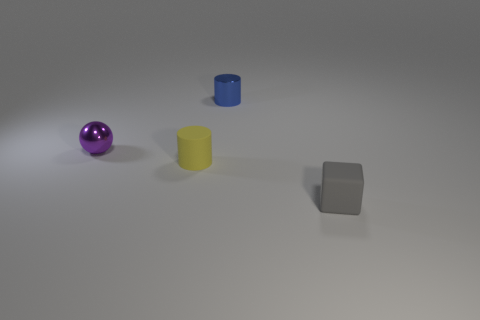The purple shiny thing is what shape? sphere 